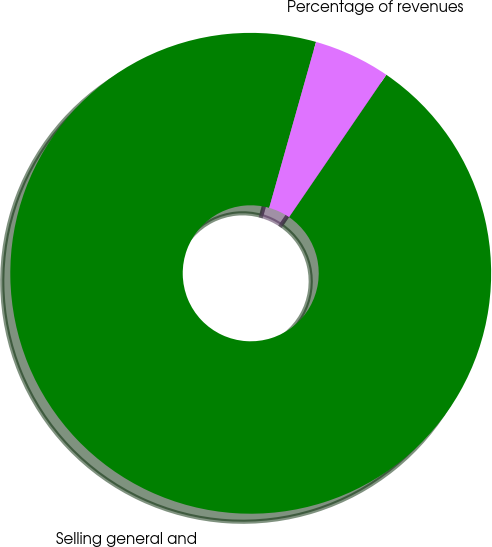Convert chart to OTSL. <chart><loc_0><loc_0><loc_500><loc_500><pie_chart><fcel>Selling general and<fcel>Percentage of revenues<nl><fcel>94.84%<fcel>5.16%<nl></chart> 